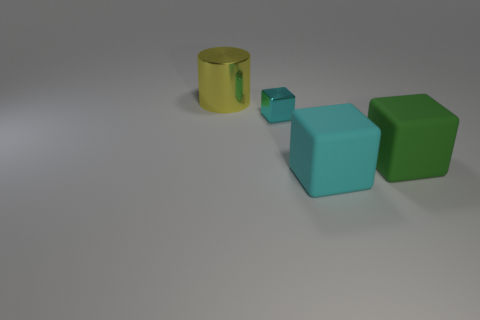How many other objects are the same material as the tiny cyan thing?
Provide a short and direct response. 1. There is a large thing that is both in front of the yellow shiny object and behind the cyan matte cube; what is its shape?
Provide a succinct answer. Cube. There is a cyan object that is in front of the green rubber cube; is it the same size as the matte block that is behind the cyan rubber block?
Ensure brevity in your answer.  Yes. What shape is the big green object that is the same material as the big cyan thing?
Offer a terse response. Cube. Are there any other things that are the same shape as the tiny cyan thing?
Offer a very short reply. Yes. What color is the cylinder behind the big green cube that is behind the large rubber cube that is to the left of the large green matte object?
Keep it short and to the point. Yellow. Are there fewer tiny cyan blocks that are to the left of the tiny cyan metal thing than metallic things to the right of the large cylinder?
Provide a short and direct response. Yes. Does the large green thing have the same shape as the large yellow object?
Offer a very short reply. No. How many blocks have the same size as the yellow cylinder?
Offer a terse response. 2. Are there fewer cyan rubber blocks that are on the left side of the large yellow thing than large cyan things?
Your answer should be compact. Yes. 